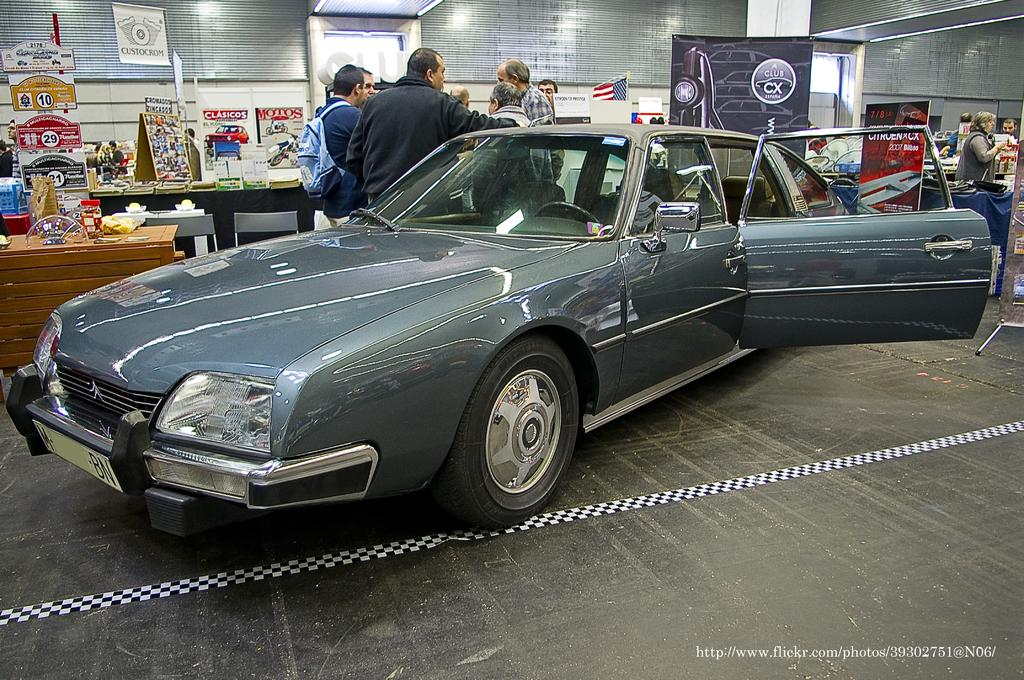What is placed on the floor in the image? There is a car on the floor in the image. What can be seen on the table in the image? There is a table with many things on it in the image. What is hanging on the wall in the image? There are banners on the wall in the image. How many clocks are visible on the car in the image? There are no clocks visible on the car in the image. Can you describe the company that is represented by the banners on the wall? The provided facts do not mention any company or its representation on the banners; we can only describe the presence of banners on the wall. 